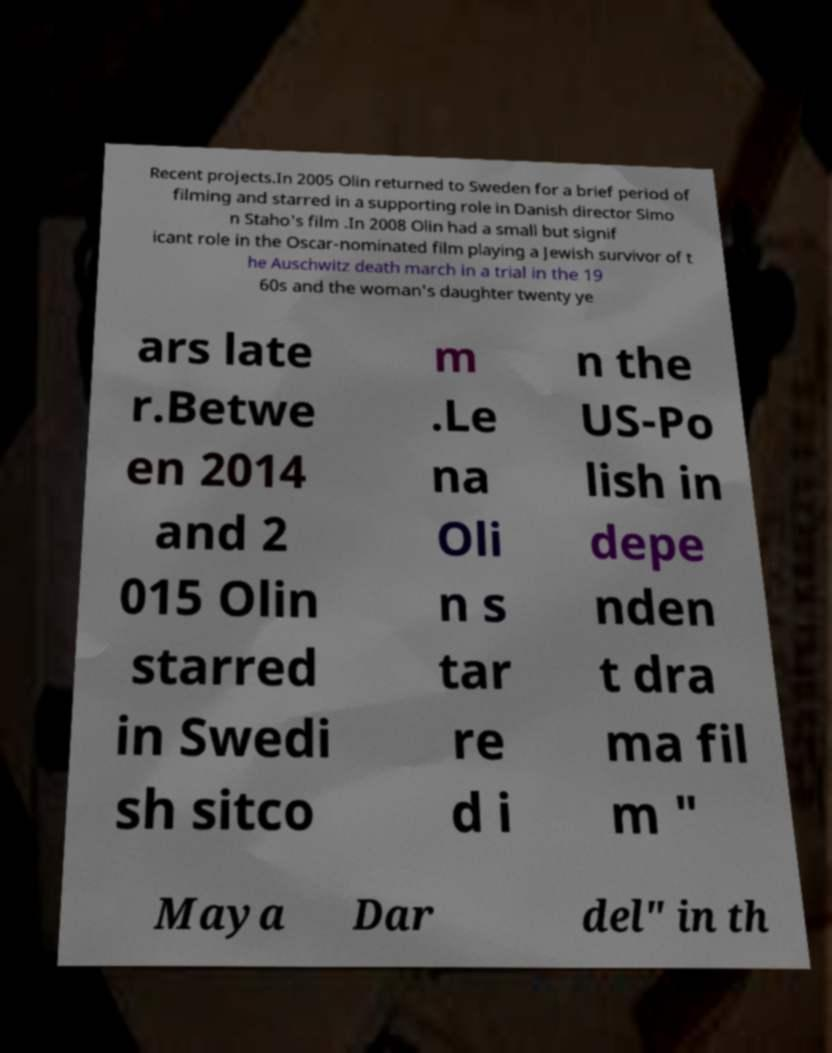Can you accurately transcribe the text from the provided image for me? Recent projects.In 2005 Olin returned to Sweden for a brief period of filming and starred in a supporting role in Danish director Simo n Staho's film .In 2008 Olin had a small but signif icant role in the Oscar-nominated film playing a Jewish survivor of t he Auschwitz death march in a trial in the 19 60s and the woman's daughter twenty ye ars late r.Betwe en 2014 and 2 015 Olin starred in Swedi sh sitco m .Le na Oli n s tar re d i n the US-Po lish in depe nden t dra ma fil m " Maya Dar del" in th 